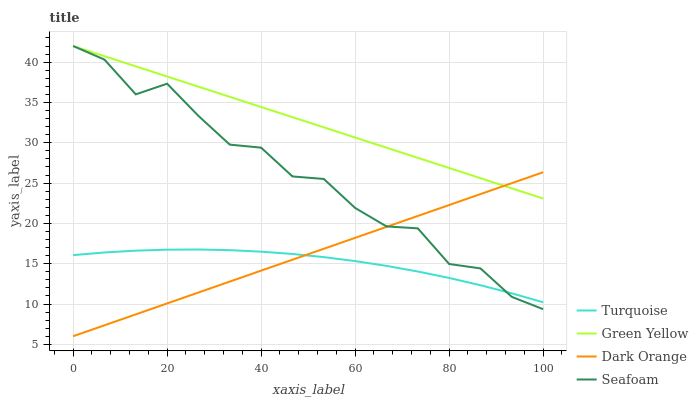Does Turquoise have the minimum area under the curve?
Answer yes or no. Yes. Does Green Yellow have the maximum area under the curve?
Answer yes or no. Yes. Does Green Yellow have the minimum area under the curve?
Answer yes or no. No. Does Turquoise have the maximum area under the curve?
Answer yes or no. No. Is Dark Orange the smoothest?
Answer yes or no. Yes. Is Seafoam the roughest?
Answer yes or no. Yes. Is Turquoise the smoothest?
Answer yes or no. No. Is Turquoise the roughest?
Answer yes or no. No. Does Turquoise have the lowest value?
Answer yes or no. No. Does Seafoam have the highest value?
Answer yes or no. Yes. Does Turquoise have the highest value?
Answer yes or no. No. Is Turquoise less than Green Yellow?
Answer yes or no. Yes. Is Green Yellow greater than Turquoise?
Answer yes or no. Yes. Does Turquoise intersect Green Yellow?
Answer yes or no. No. 